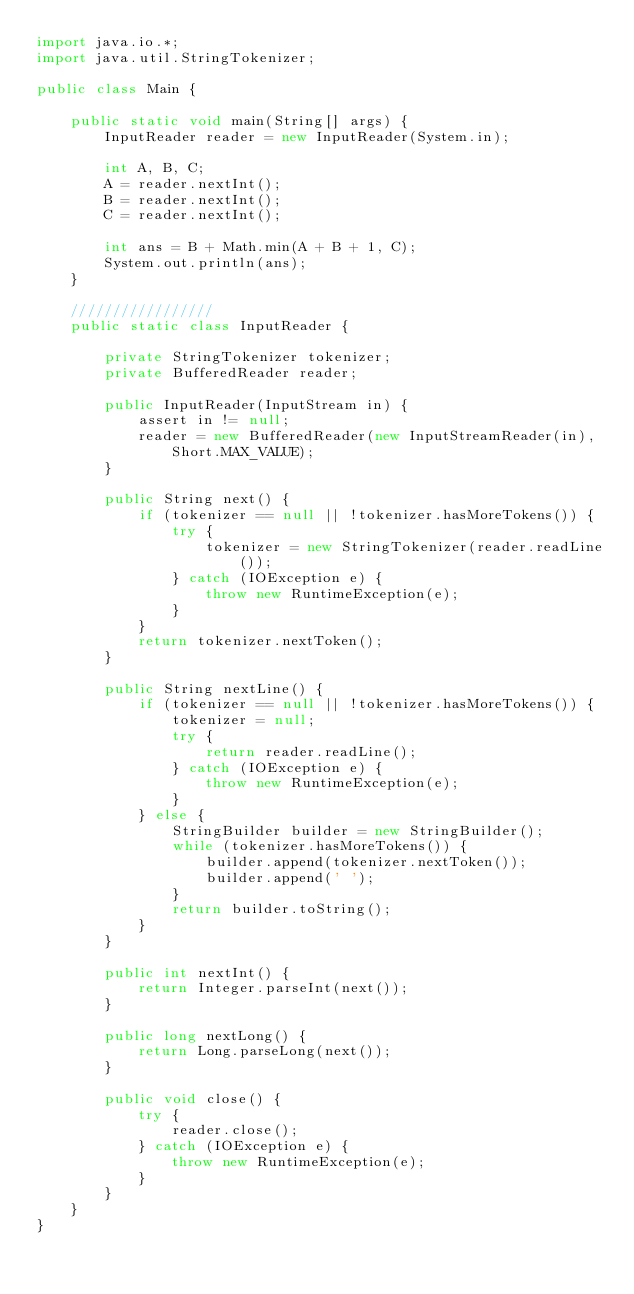Convert code to text. <code><loc_0><loc_0><loc_500><loc_500><_Java_>import java.io.*;
import java.util.StringTokenizer;

public class Main {

    public static void main(String[] args) {
        InputReader reader = new InputReader(System.in);

        int A, B, C;
        A = reader.nextInt();
        B = reader.nextInt();
        C = reader.nextInt();

        int ans = B + Math.min(A + B + 1, C);
        System.out.println(ans);
    }

    /////////////////
    public static class InputReader {

        private StringTokenizer tokenizer;
        private BufferedReader reader;

        public InputReader(InputStream in) {
            assert in != null;
            reader = new BufferedReader(new InputStreamReader(in), Short.MAX_VALUE);
        }

        public String next() {
            if (tokenizer == null || !tokenizer.hasMoreTokens()) {
                try {
                    tokenizer = new StringTokenizer(reader.readLine());
                } catch (IOException e) {
                    throw new RuntimeException(e);
                }
            }
            return tokenizer.nextToken();
        }

        public String nextLine() {
            if (tokenizer == null || !tokenizer.hasMoreTokens()) {
                tokenizer = null;
                try {
                    return reader.readLine();
                } catch (IOException e) {
                    throw new RuntimeException(e);
                }
            } else {
                StringBuilder builder = new StringBuilder();
                while (tokenizer.hasMoreTokens()) {
                    builder.append(tokenizer.nextToken());
                    builder.append(' ');
                }
                return builder.toString();
            }
        }

        public int nextInt() {
            return Integer.parseInt(next());
        }

        public long nextLong() {
            return Long.parseLong(next());
        }

        public void close() {
            try {
                reader.close();
            } catch (IOException e) {
                throw new RuntimeException(e);
            }
        }
    }
}
</code> 